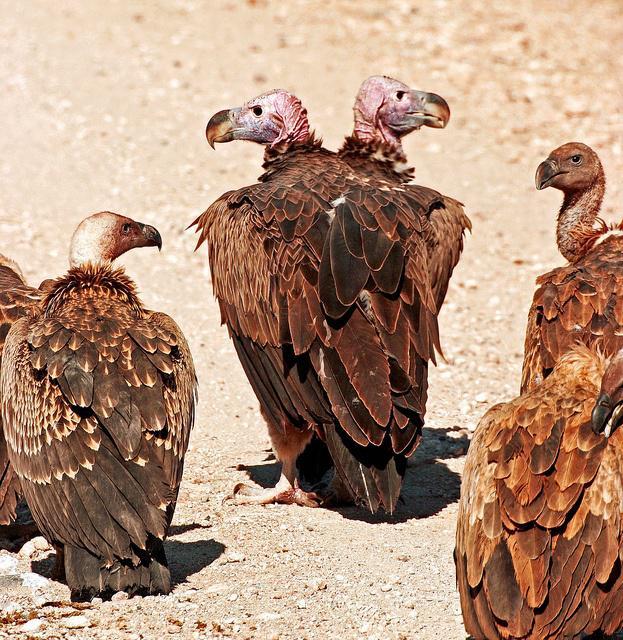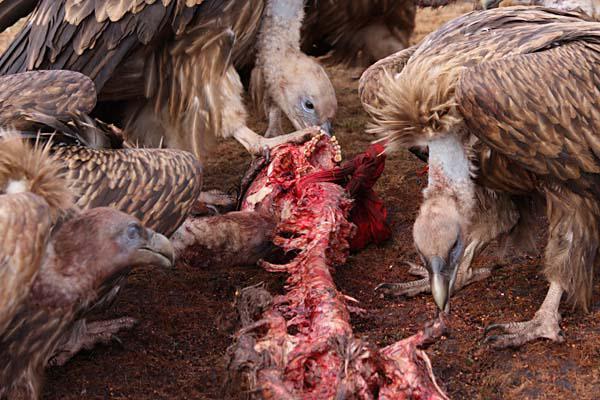The first image is the image on the left, the second image is the image on the right. For the images shown, is this caption "There are more than 5 vulture eating an animal with a set of horns that are visible." true? Answer yes or no. No. The first image is the image on the left, the second image is the image on the right. Examine the images to the left and right. Is the description "The vultures in the image on the right are squabbling over bloody remains in an arid, brown landscape with no green grass." accurate? Answer yes or no. Yes. 